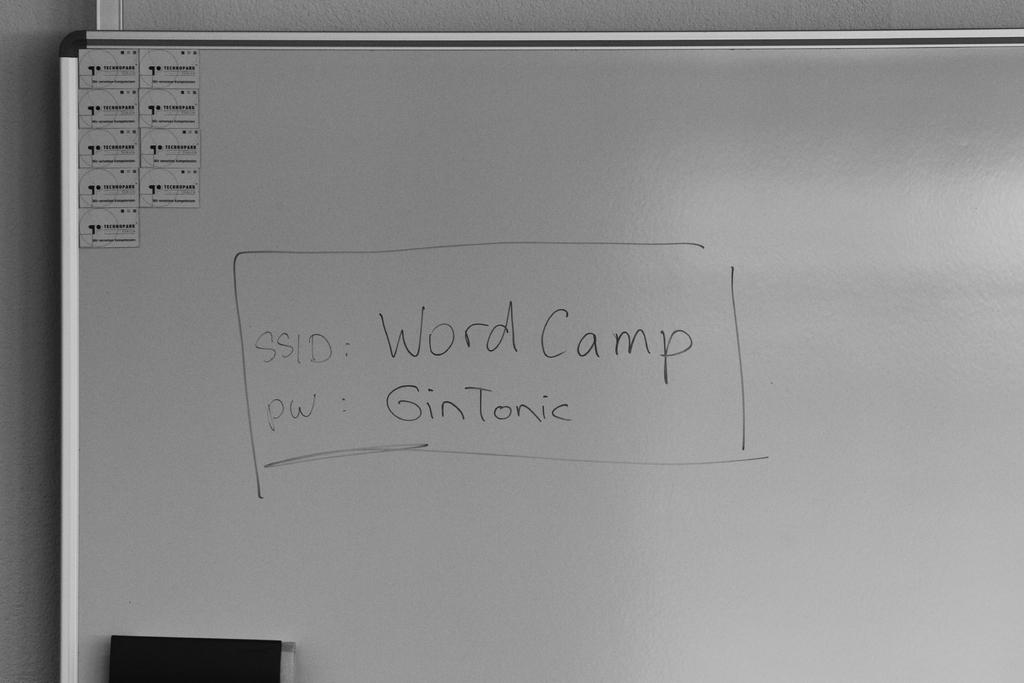<image>
Provide a brief description of the given image. A whiteboard that shows that the SSID is WordCamp and pw is GinTonic. 